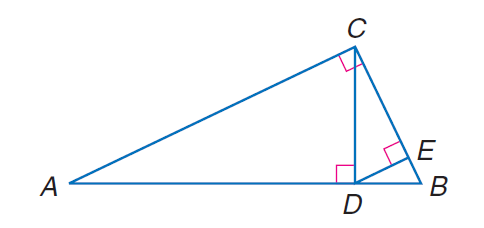Question: Find the exact value of D E, given A D = 12 and B D = 4.
Choices:
A. 2 \sqrt { 3 }
B. 2 \sqrt { 6 }
C. 4 \sqrt { 3 }
D. 4 \sqrt { 6 }
Answer with the letter. Answer: A 